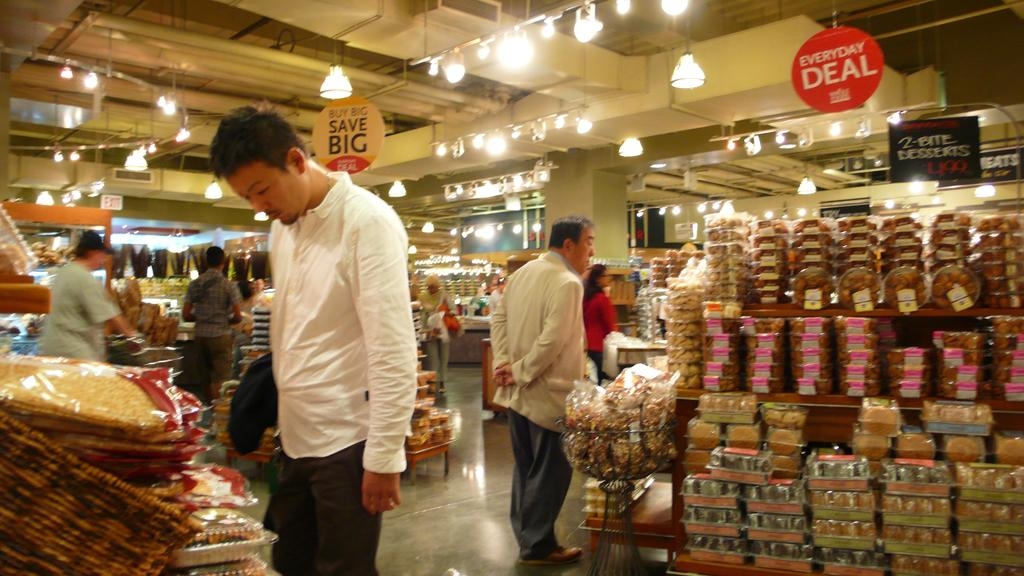<image>
Offer a succinct explanation of the picture presented. Man looking for groceries behind a sign that says Everyday Deal. 